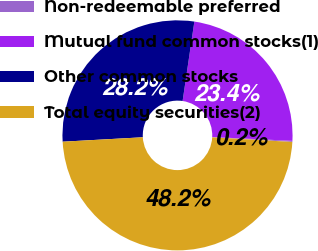<chart> <loc_0><loc_0><loc_500><loc_500><pie_chart><fcel>Non-redeemable preferred<fcel>Mutual fund common stocks(1)<fcel>Other common stocks<fcel>Total equity securities(2)<nl><fcel>0.15%<fcel>23.42%<fcel>28.22%<fcel>48.21%<nl></chart> 